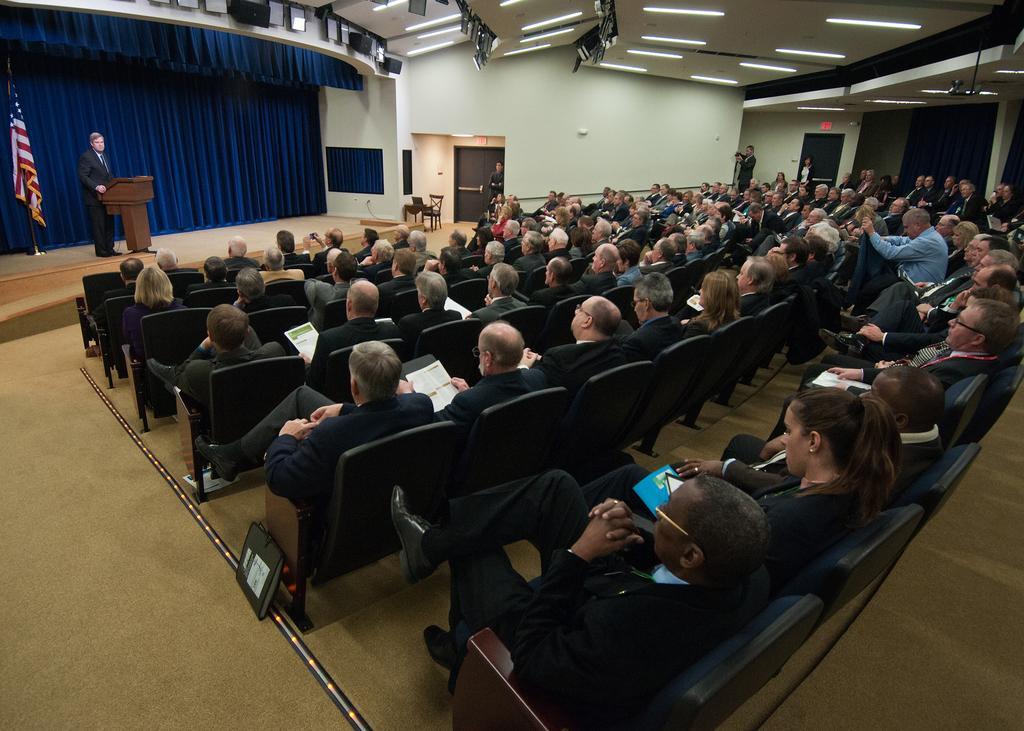Describe this image in one or two sentences. On the left side of the image we can see a person is standing, a flag and curtains are there. In the middle of the image we can see a group of people is sitting on the chairs and a door is there. On the right side of the image we can see group of people is sitting on chairs and some lights are there. 